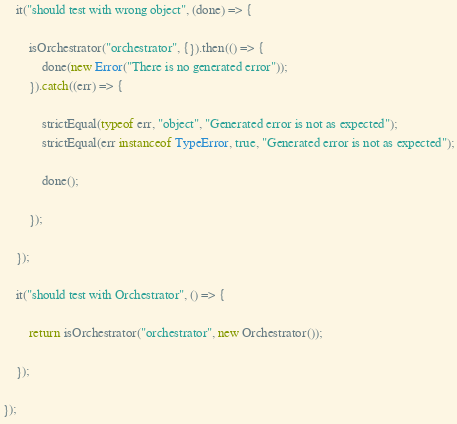<code> <loc_0><loc_0><loc_500><loc_500><_JavaScript_>	it("should test with wrong object", (done) => {

		isOrchestrator("orchestrator", {}).then(() => {
			done(new Error("There is no generated error"));
		}).catch((err) => {

			strictEqual(typeof err, "object", "Generated error is not as expected");
			strictEqual(err instanceof TypeError, true, "Generated error is not as expected");

			done();

		});

	});

	it("should test with Orchestrator", () => {

		return isOrchestrator("orchestrator", new Orchestrator());

	});

});
</code> 